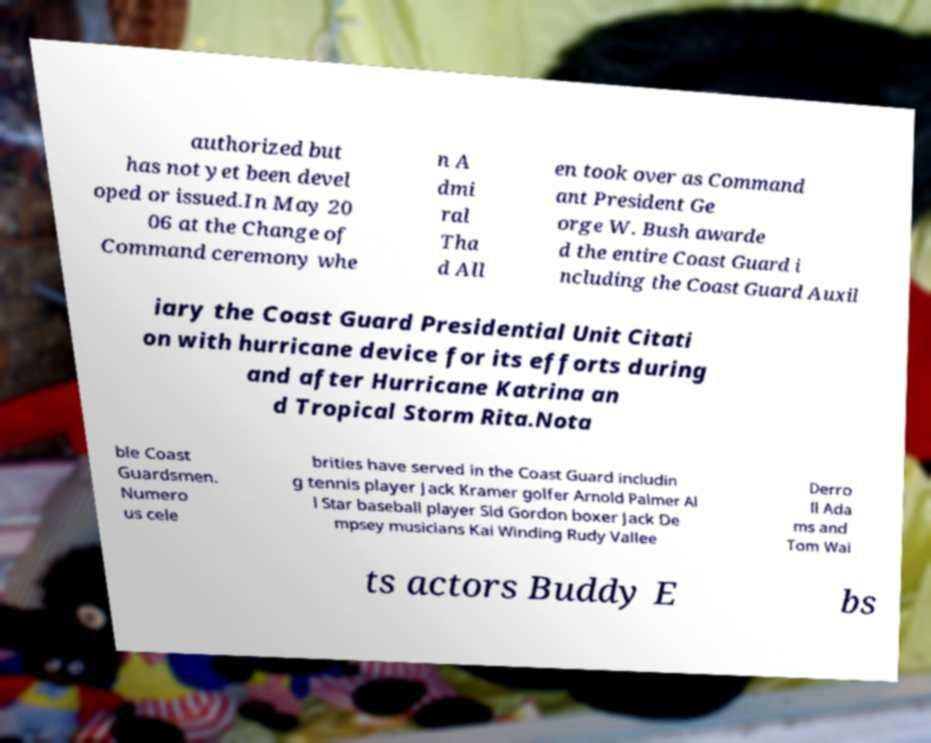For documentation purposes, I need the text within this image transcribed. Could you provide that? authorized but has not yet been devel oped or issued.In May 20 06 at the Change of Command ceremony whe n A dmi ral Tha d All en took over as Command ant President Ge orge W. Bush awarde d the entire Coast Guard i ncluding the Coast Guard Auxil iary the Coast Guard Presidential Unit Citati on with hurricane device for its efforts during and after Hurricane Katrina an d Tropical Storm Rita.Nota ble Coast Guardsmen. Numero us cele brities have served in the Coast Guard includin g tennis player Jack Kramer golfer Arnold Palmer Al l Star baseball player Sid Gordon boxer Jack De mpsey musicians Kai Winding Rudy Vallee Derro ll Ada ms and Tom Wai ts actors Buddy E bs 